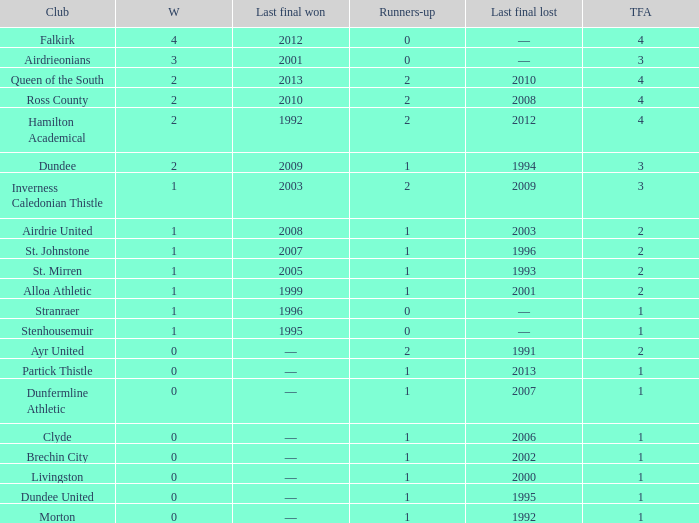Would you be able to parse every entry in this table? {'header': ['Club', 'W', 'Last final won', 'Runners-up', 'Last final lost', 'TFA'], 'rows': [['Falkirk', '4', '2012', '0', '—', '4'], ['Airdrieonians', '3', '2001', '0', '—', '3'], ['Queen of the South', '2', '2013', '2', '2010', '4'], ['Ross County', '2', '2010', '2', '2008', '4'], ['Hamilton Academical', '2', '1992', '2', '2012', '4'], ['Dundee', '2', '2009', '1', '1994', '3'], ['Inverness Caledonian Thistle', '1', '2003', '2', '2009', '3'], ['Airdrie United', '1', '2008', '1', '2003', '2'], ['St. Johnstone', '1', '2007', '1', '1996', '2'], ['St. Mirren', '1', '2005', '1', '1993', '2'], ['Alloa Athletic', '1', '1999', '1', '2001', '2'], ['Stranraer', '1', '1996', '0', '—', '1'], ['Stenhousemuir', '1', '1995', '0', '—', '1'], ['Ayr United', '0', '—', '2', '1991', '2'], ['Partick Thistle', '0', '—', '1', '2013', '1'], ['Dunfermline Athletic', '0', '—', '1', '2007', '1'], ['Clyde', '0', '—', '1', '2006', '1'], ['Brechin City', '0', '—', '1', '2002', '1'], ['Livingston', '0', '—', '1', '2000', '1'], ['Dundee United', '0', '—', '1', '1995', '1'], ['Morton', '0', '—', '1', '1992', '1']]} What club has over 1 runners-up and last won the final in 2010? Ross County. 